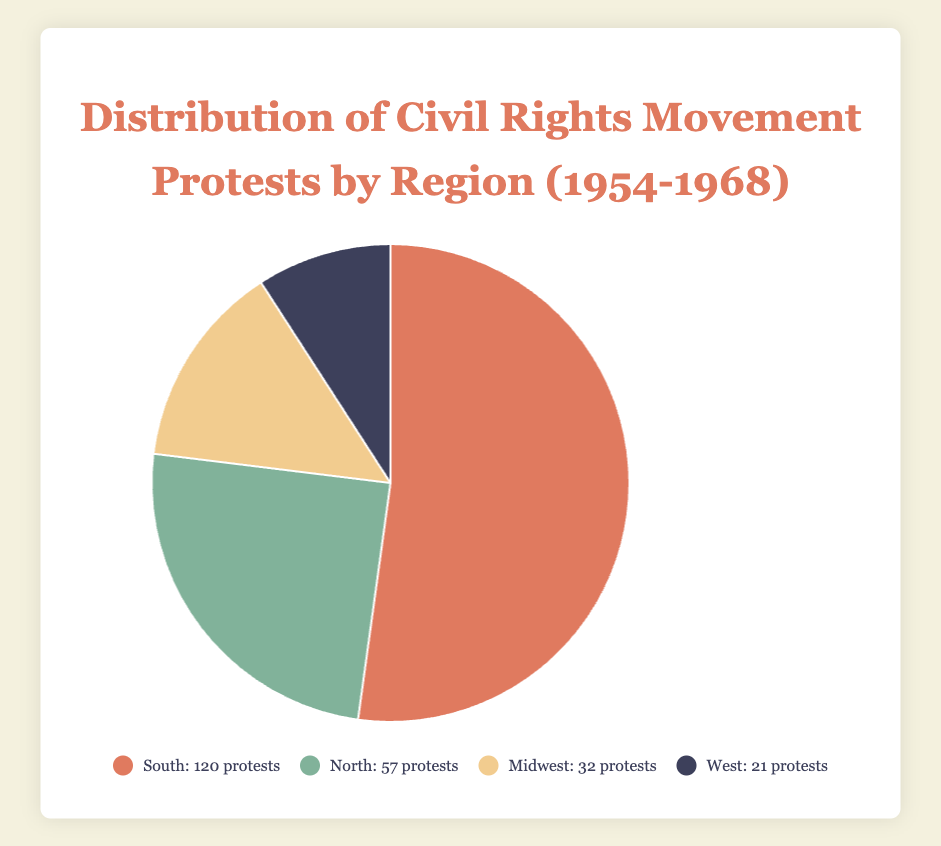Which region had the highest number of protests? By observing the sizes of the sections in the pie chart and the legend, we can see that the "South" region had the largest portion of the pie, indicating it had the highest number of protests with 120 protests in total.
Answer: South Which region had the smallest number of protests? Looking at the smallest section of the pie chart, we see that the "West" region had the smallest portion, indicating it had the lowest number with 21 protests.
Answer: West How does the number of protests in the South compare to the combined total of the Midwest and West? The South has 120 protests. The combined total of the Midwest and West is 32 (Midwest) + 21 (West) = 53 protests. Therefore, the South has a higher number of protests compared to the sum of the Midwest and West.
Answer: South has more protests What is the percentage of protests in the North out of the total protests? The North had 57 protests. The total number of protests across all regions is 120 (South) + 57 (North) + 32 (Midwest) + 21 (West) = 230 protests. The percentage is (57 / 230) * 100 ≈ 24.78%
Answer: ~24.78% Are there more protests in the North and Midwest combined than in the South alone? The combined total of protests in the North and Midwest is 57 (North) + 32 (Midwest) = 89 protests. Since the South had 120 protests, the South had more protests than the combined total of the North and Midwest.
Answer: No, South has more What is the visual representation of the region with the second highest number of protests? The second largest section of the pie chart represents the North with 57 protests. This section is visually the second largest and is color-coded with a green hue.
Answer: North (green) If you combine the protests from the West and North, how does this total compare with the Midwest? The combined total for the West and North is 21 (West) + 57 (North) = 78 protests. The Midwest had 32 protests. So, the combined total of the West and North is higher than the Midwest.
Answer: Combined total is higher What is the difference in the count of protests between the South and the North? The count difference between the South (120 protests) and the North (57 protests) is 120 - 57 = 63 protests.
Answer: 63 protests Calculate the average number of protests across all regions. The total number of protests is 120 (South) + 57 (North) + 32 (Midwest) + 21 (West) = 230 protests. There are 4 regions. The average is 230 / 4 = 57.5 protests.
Answer: 57.5 protests 